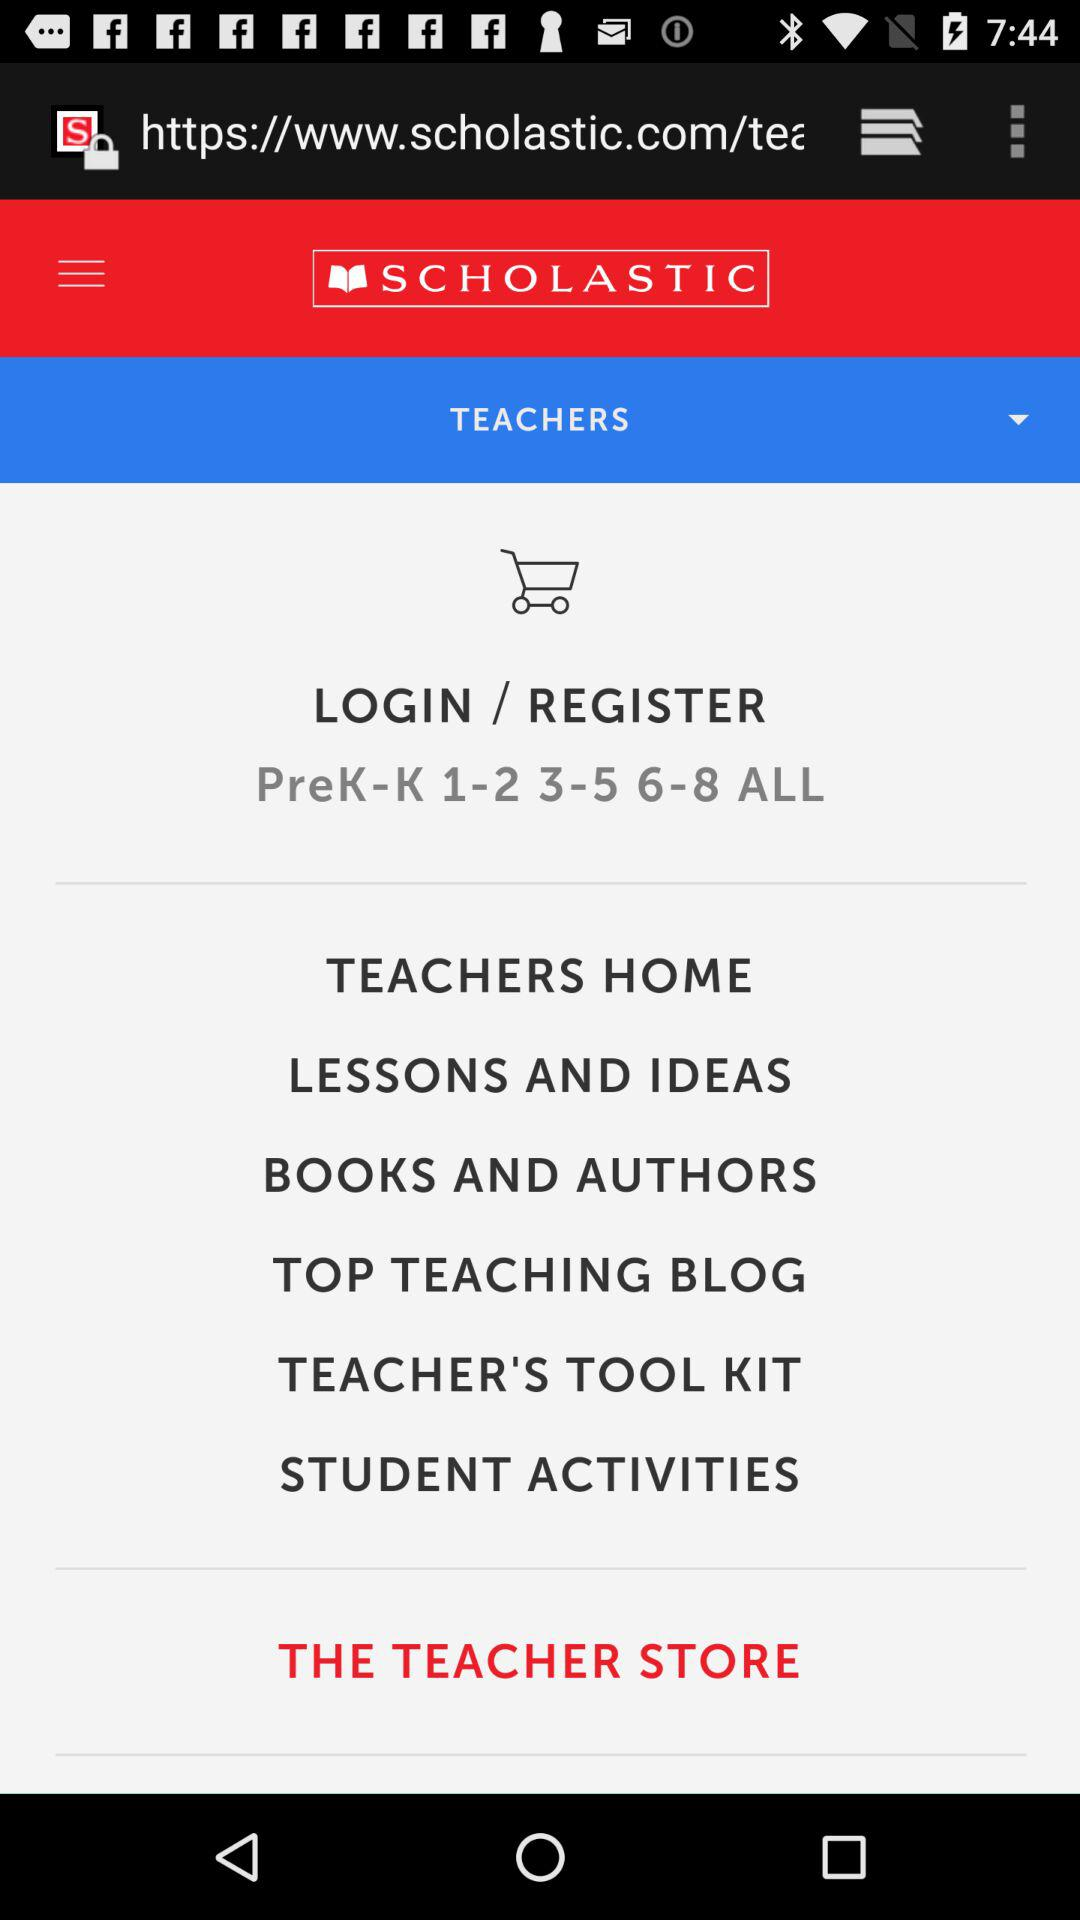What is the name of the website? The name of the website is "SCHOLASTIC". 